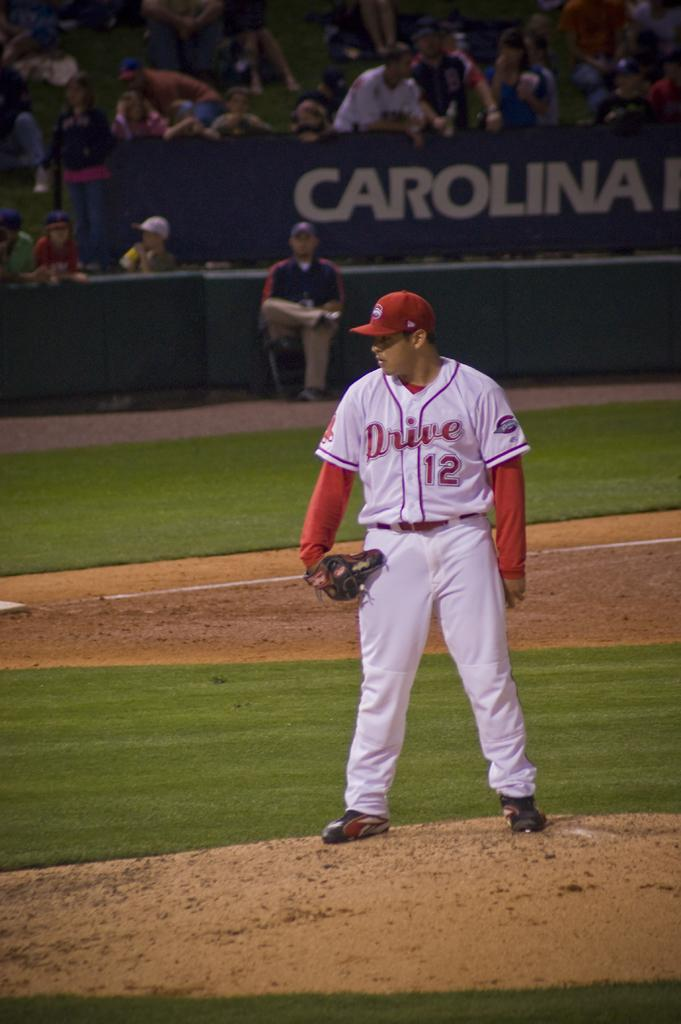<image>
Describe the image concisely. a baseball player with a red uniform with drive 12 printed on it. 